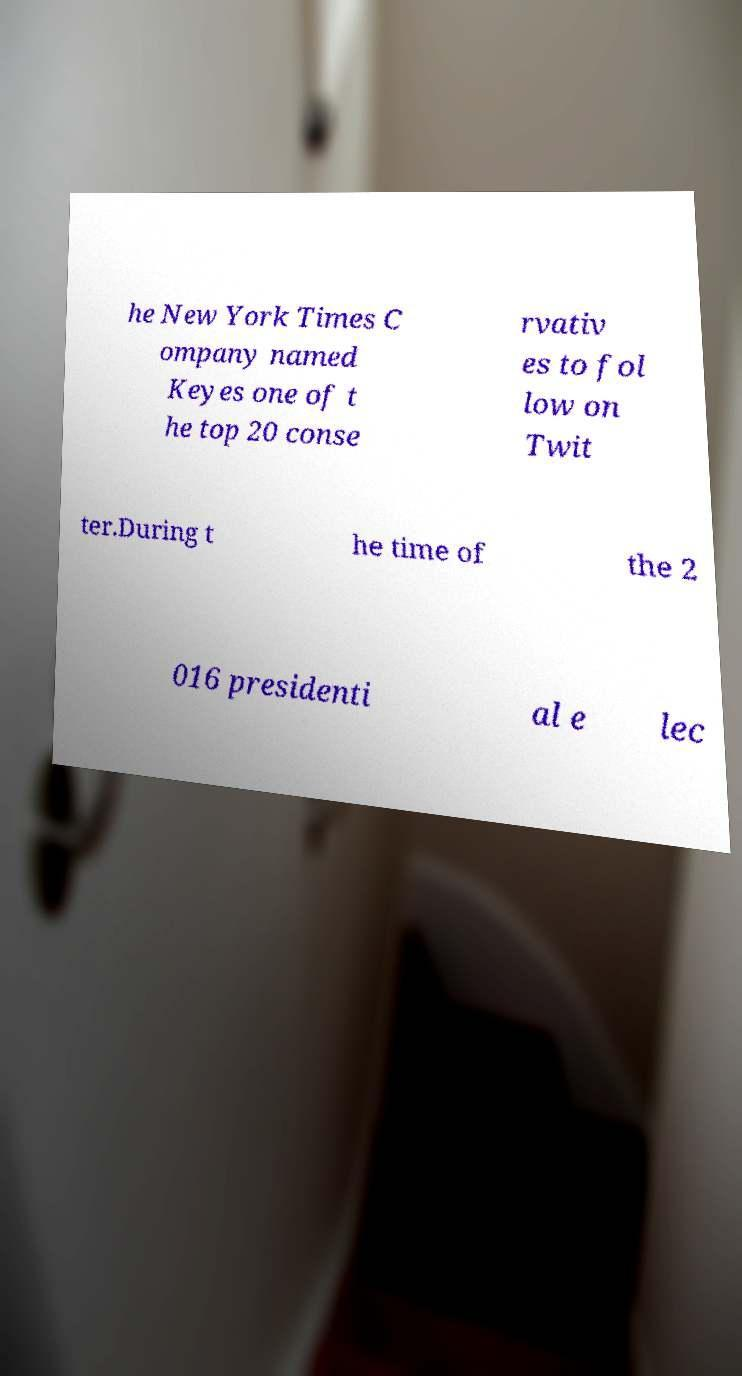Can you accurately transcribe the text from the provided image for me? he New York Times C ompany named Keyes one of t he top 20 conse rvativ es to fol low on Twit ter.During t he time of the 2 016 presidenti al e lec 